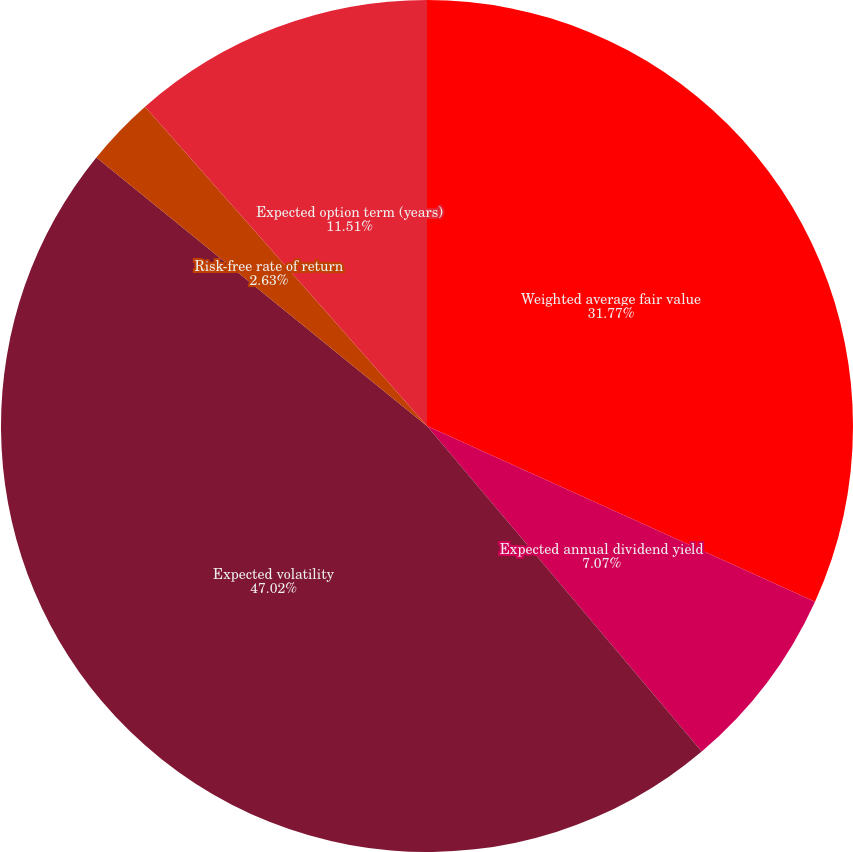Convert chart. <chart><loc_0><loc_0><loc_500><loc_500><pie_chart><fcel>Weighted average fair value<fcel>Expected annual dividend yield<fcel>Expected volatility<fcel>Risk-free rate of return<fcel>Expected option term (years)<nl><fcel>31.77%<fcel>7.07%<fcel>47.01%<fcel>2.63%<fcel>11.51%<nl></chart> 